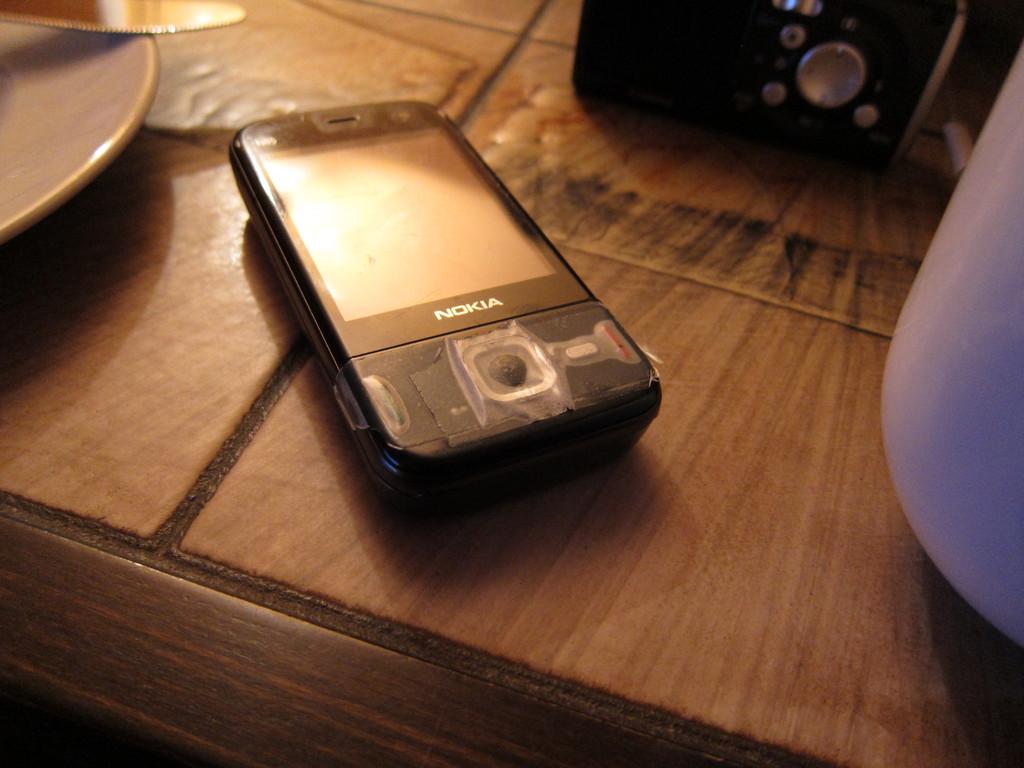What kind of cell phone is that?
Your answer should be compact. Nokia. 